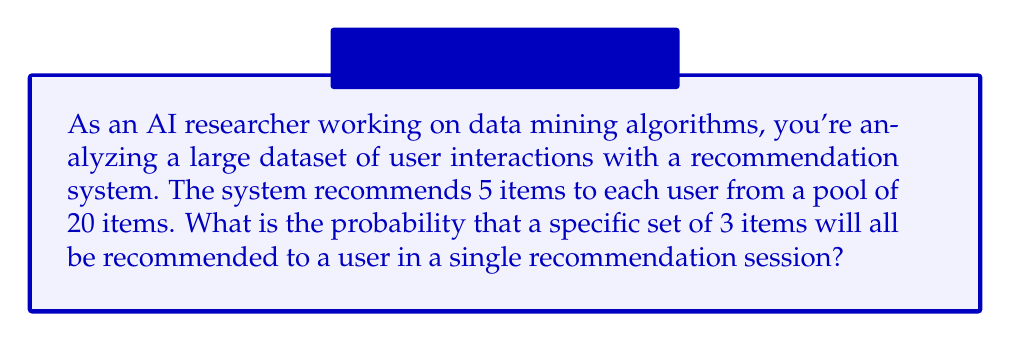Can you answer this question? To solve this problem, we'll use combinatorics and probability theory. Let's break it down step-by-step:

1) First, we need to calculate the total number of possible combinations of 5 items chosen from 20. This is given by the combination formula:

   $$\binom{20}{5} = \frac{20!}{5!(20-5)!} = \frac{20!}{5!15!}$$

2) Next, we need to consider that we want 3 specific items to be included in the 5 recommended items. This means we need to choose the remaining 2 items from the 17 items left (20 - 3 = 17). This is given by:

   $$\binom{17}{2} = \frac{17!}{2!15!}$$

3) The probability is then the number of favorable outcomes divided by the total number of possible outcomes:

   $$P(\text{3 specific items in recommendation}) = \frac{\binom{17}{2}}{\binom{20}{5}}$$

4) Let's calculate these values:

   $$\binom{20}{5} = \frac{20!}{5!15!} = 15504$$

   $$\binom{17}{2} = \frac{17!}{2!15!} = 136$$

5) Now we can calculate the probability:

   $$P(\text{3 specific items in recommendation}) = \frac{136}{15504} = \frac{17}{1938} \approx 0.00877$$
Answer: The probability is $\frac{17}{1938}$ or approximately 0.00877 (0.877%). 